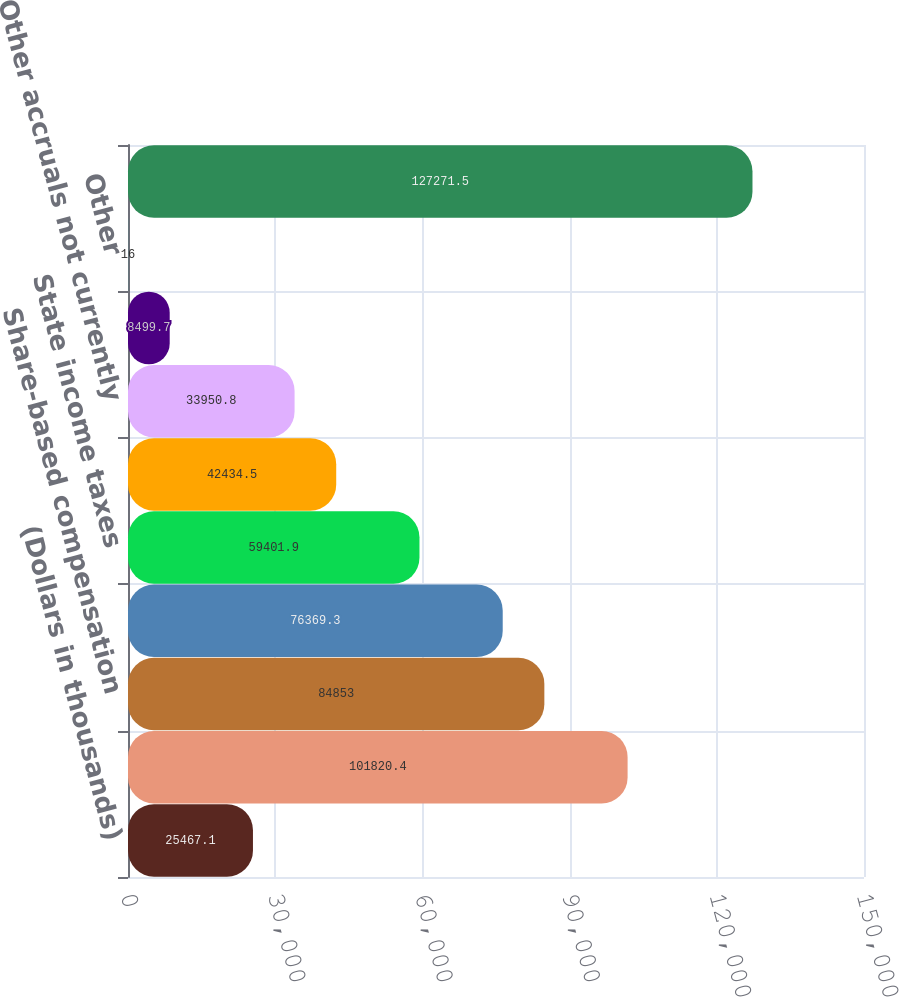Convert chart to OTSL. <chart><loc_0><loc_0><loc_500><loc_500><bar_chart><fcel>(Dollars in thousands)<fcel>Allowance for loan losses<fcel>Share-based compensation<fcel>Loan fee income<fcel>State income taxes<fcel>Net operating loss<fcel>Other accruals not currently<fcel>Research and development<fcel>Other<fcel>Deferred tax assets<nl><fcel>25467.1<fcel>101820<fcel>84853<fcel>76369.3<fcel>59401.9<fcel>42434.5<fcel>33950.8<fcel>8499.7<fcel>16<fcel>127272<nl></chart> 